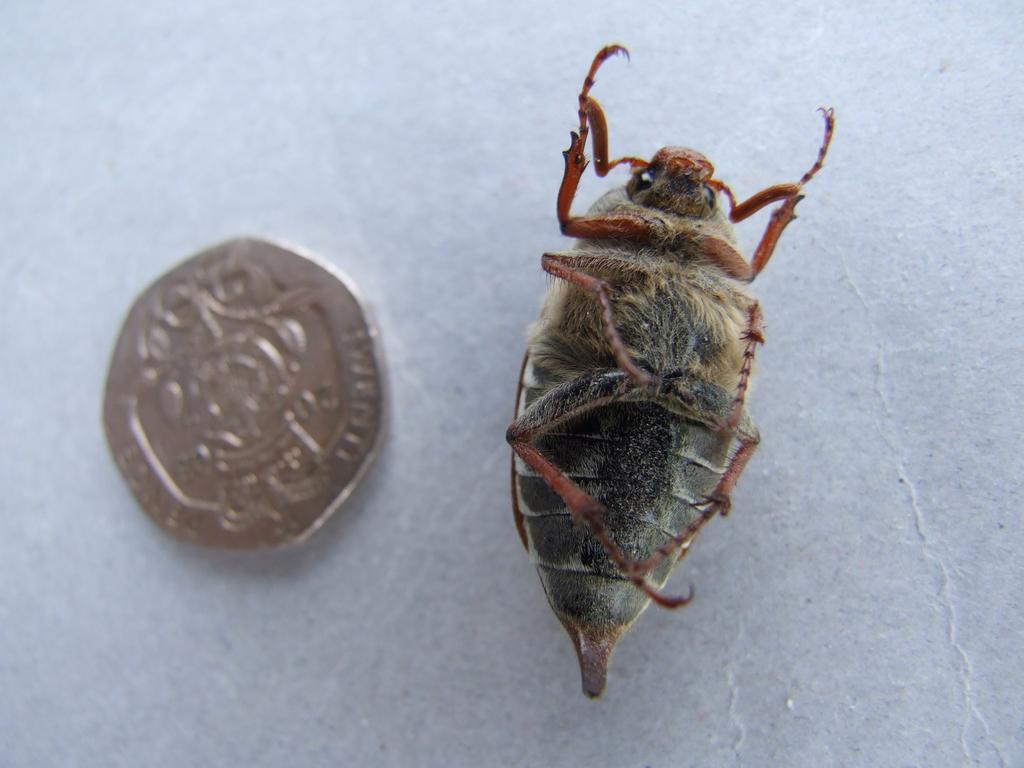How would you summarize this image in a sentence or two? In this image I can see an insect which is in black and brown color. To the side I can see the coin. These are on the white color surface. 